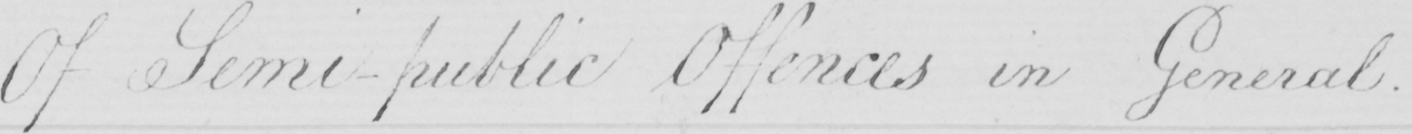What is written in this line of handwriting? Of Semi-public Offences in General . 